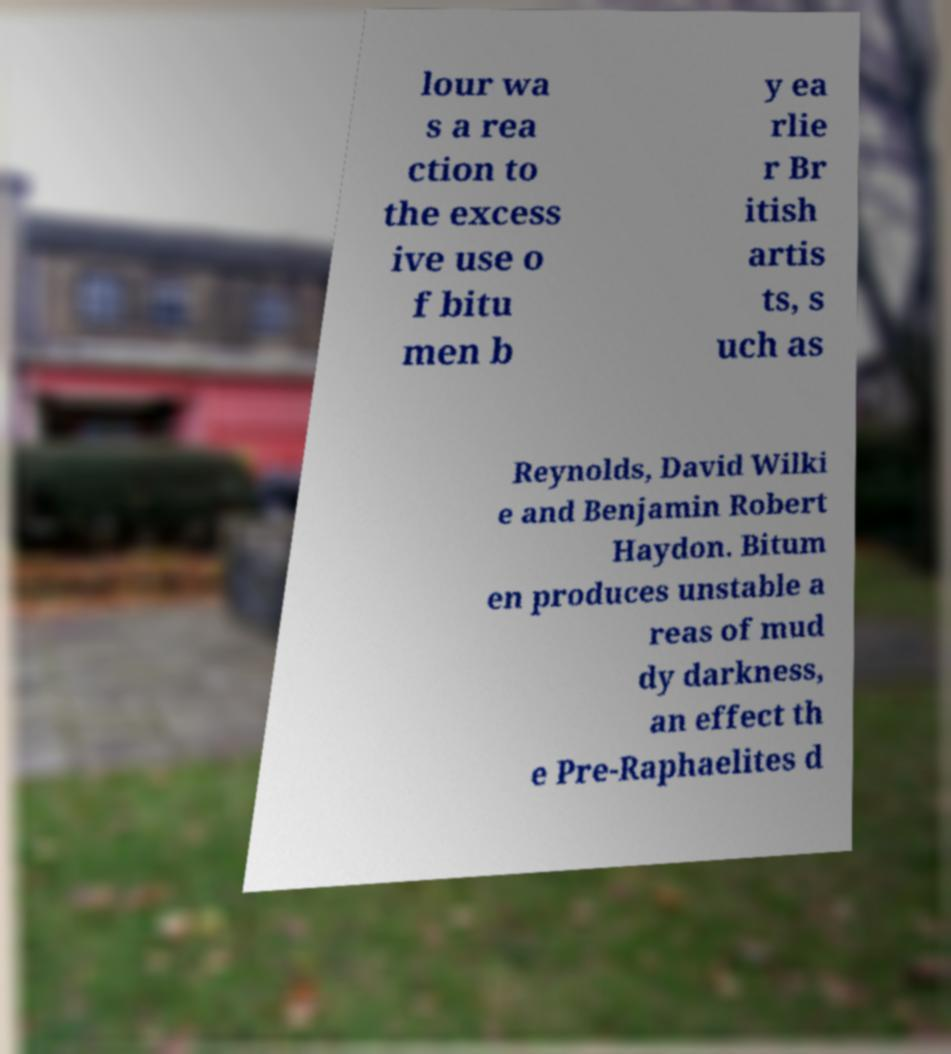Could you extract and type out the text from this image? lour wa s a rea ction to the excess ive use o f bitu men b y ea rlie r Br itish artis ts, s uch as Reynolds, David Wilki e and Benjamin Robert Haydon. Bitum en produces unstable a reas of mud dy darkness, an effect th e Pre-Raphaelites d 